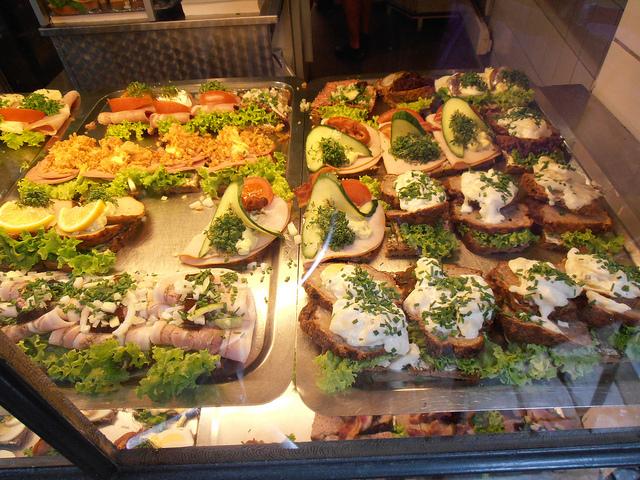Is this food cold?
Short answer required. Yes. Are these appetizer's in a restaurant?
Short answer required. Yes. Is this healthy?
Give a very brief answer. Yes. 